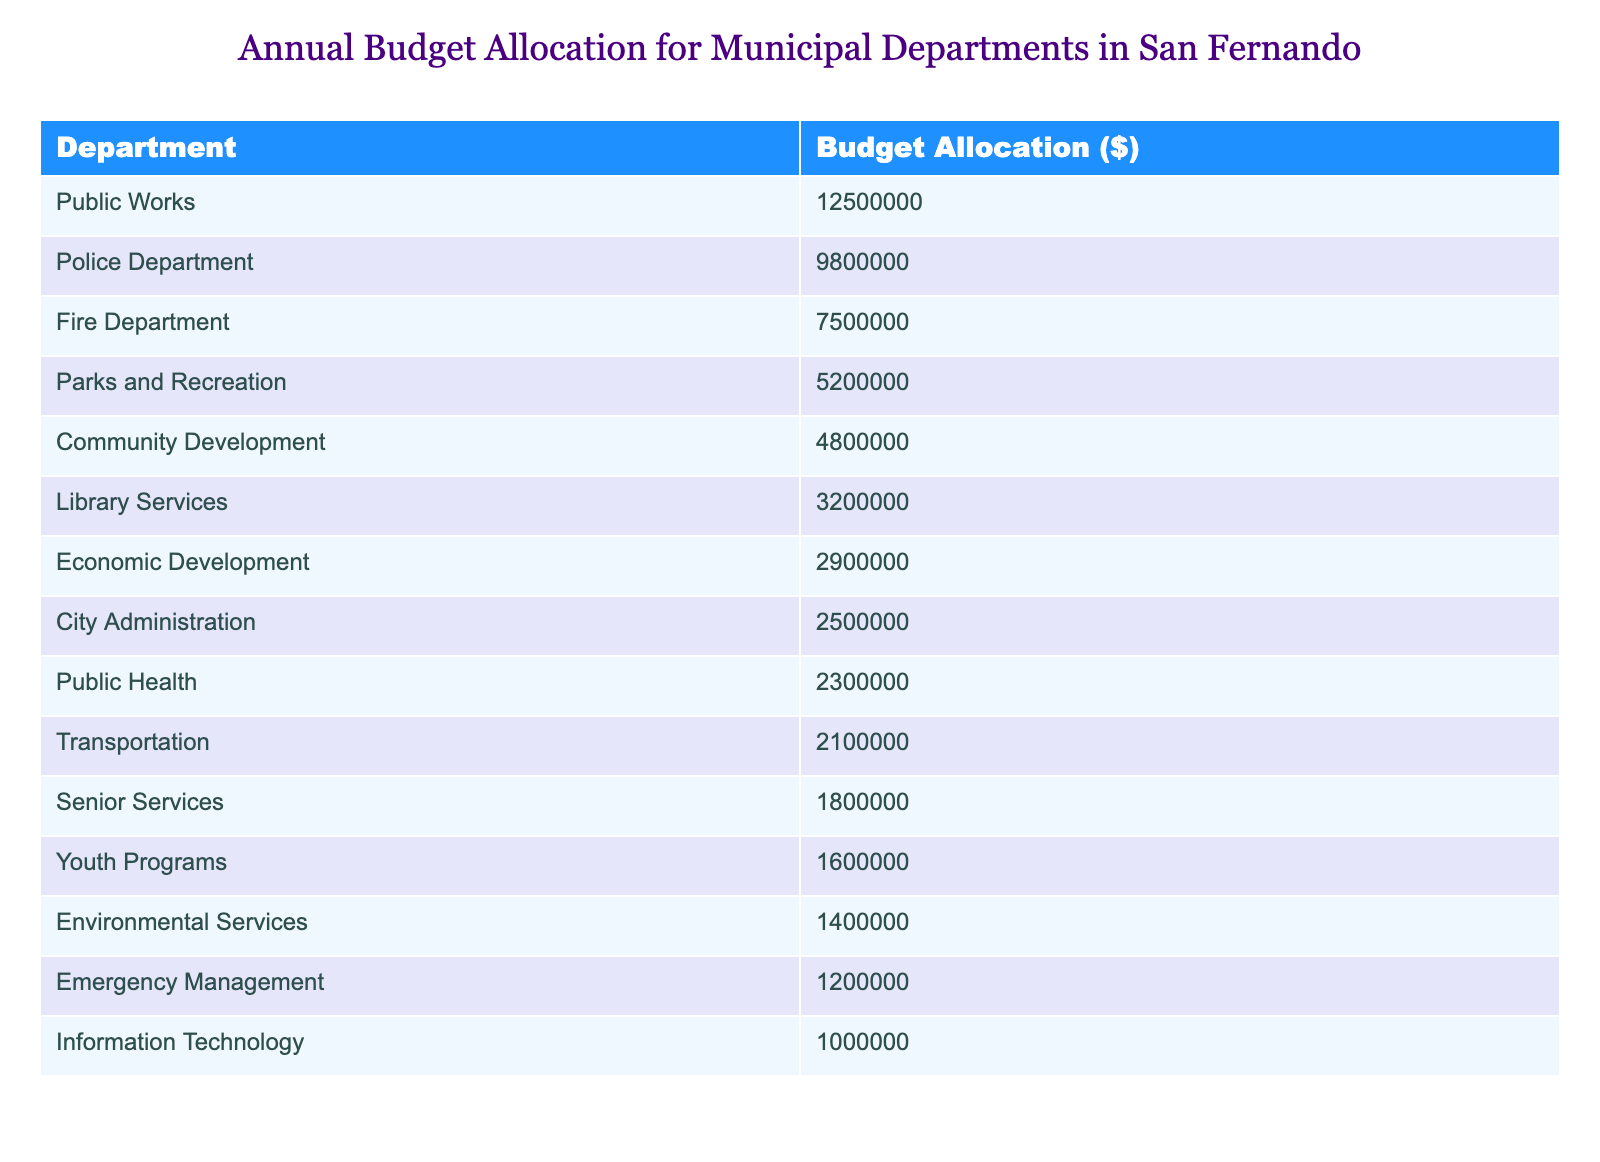What is the budget allocation for the Police Department? The table lists the budget allocation specifically for the Police Department, which shows the figure of 9,800,000 dollars.
Answer: 9,800,000 Which department has the highest budget allocation? By examining the budget allocations, Public Works has the highest budget at 12,500,000 dollars, more than any other department listed.
Answer: Public Works What is the total budget allocation for the Fire Department and the Parks and Recreation Department combined? The budget allocation for the Fire Department is 7,500,000 dollars and for Parks and Recreation is 5,200,000 dollars. Adding these amounts together gives 7,500,000 + 5,200,000 = 12,700,000 dollars.
Answer: 12,700,000 Is the budget allocation for Senior Services greater than that for Youth Programs? The allocation for Senior Services is 1,800,000 dollars, while for Youth Programs it is 1,600,000 dollars. Since 1,800,000 is greater than 1,600,000, the statement is true.
Answer: Yes What is the difference in budget allocation between Economic Development and Transportation? Economic Development has a budget of 2,900,000 dollars, while Transportation has 2,100,000 dollars. The difference is calculated by subtracting the two: 2,900,000 - 2,100,000 = 800,000 dollars.
Answer: 800,000 What is the average budget allocation of the bottom three departments? The departments with the lowest budgets listed are Emergency Management (1,200,000), Information Technology (1,000,000), and Youth Programs (1,600,000). Adding these gives 1,200,000 + 1,000,000 + 1,600,000 = 3,800,000. The average is found by dividing by 3, which is 3,800,000 / 3 = 1,266,666.67 dollars.
Answer: 1,266,666.67 Does the total budget allocation for Public Health and Library Services exceed the allocation for the Police Department? The allocation for Public Health is 2,300,000 dollars and for Library Services is 3,200,000 dollars. Together, they total 2,300,000 + 3,200,000 = 5,500,000 dollars, which is less than the Police Department's allocation of 9,800,000 dollars. Therefore, the statement is false.
Answer: No If we combined the budgets of Community Development and Parks and Recreation, what would be the total? The budget for Community Development is 4,800,000 dollars and for Parks and Recreation, it is 5,200,000 dollars. Adding these together provides 4,800,000 + 5,200,000 = 10,000,000 dollars.
Answer: 10,000,000 How many departments have a budget allocation greater than 5 million dollars? By reviewing the table, the departments with budget allocations above 5 million dollars include Public Works, Police Department, Fire Department, and Parks and Recreation. In total, there are four departments that meet this criterion.
Answer: 4 